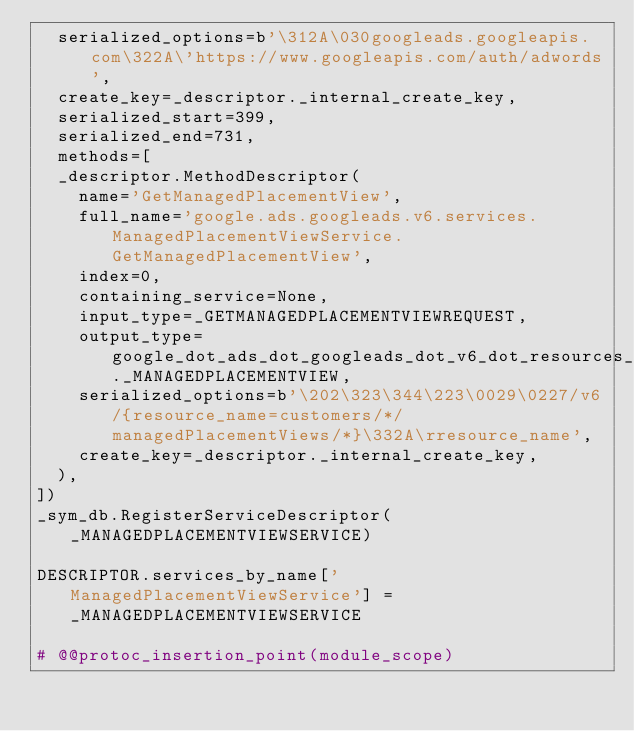Convert code to text. <code><loc_0><loc_0><loc_500><loc_500><_Python_>  serialized_options=b'\312A\030googleads.googleapis.com\322A\'https://www.googleapis.com/auth/adwords',
  create_key=_descriptor._internal_create_key,
  serialized_start=399,
  serialized_end=731,
  methods=[
  _descriptor.MethodDescriptor(
    name='GetManagedPlacementView',
    full_name='google.ads.googleads.v6.services.ManagedPlacementViewService.GetManagedPlacementView',
    index=0,
    containing_service=None,
    input_type=_GETMANAGEDPLACEMENTVIEWREQUEST,
    output_type=google_dot_ads_dot_googleads_dot_v6_dot_resources_dot_managed__placement__view__pb2._MANAGEDPLACEMENTVIEW,
    serialized_options=b'\202\323\344\223\0029\0227/v6/{resource_name=customers/*/managedPlacementViews/*}\332A\rresource_name',
    create_key=_descriptor._internal_create_key,
  ),
])
_sym_db.RegisterServiceDescriptor(_MANAGEDPLACEMENTVIEWSERVICE)

DESCRIPTOR.services_by_name['ManagedPlacementViewService'] = _MANAGEDPLACEMENTVIEWSERVICE

# @@protoc_insertion_point(module_scope)
</code> 